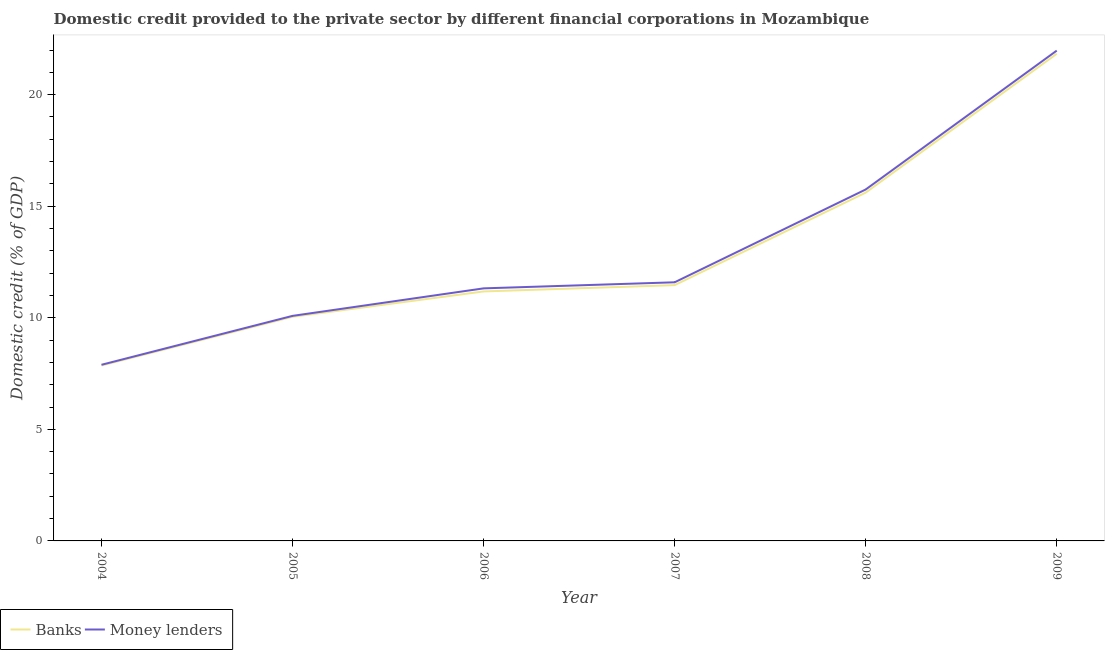How many different coloured lines are there?
Your answer should be very brief. 2. Is the number of lines equal to the number of legend labels?
Your response must be concise. Yes. What is the domestic credit provided by banks in 2007?
Ensure brevity in your answer.  11.46. Across all years, what is the maximum domestic credit provided by money lenders?
Ensure brevity in your answer.  21.97. Across all years, what is the minimum domestic credit provided by banks?
Provide a short and direct response. 7.86. In which year was the domestic credit provided by money lenders minimum?
Make the answer very short. 2004. What is the total domestic credit provided by banks in the graph?
Give a very brief answer. 77.99. What is the difference between the domestic credit provided by money lenders in 2004 and that in 2008?
Give a very brief answer. -7.86. What is the difference between the domestic credit provided by banks in 2005 and the domestic credit provided by money lenders in 2004?
Your response must be concise. 2.15. What is the average domestic credit provided by banks per year?
Offer a very short reply. 13. In the year 2005, what is the difference between the domestic credit provided by money lenders and domestic credit provided by banks?
Keep it short and to the point. 0.04. What is the ratio of the domestic credit provided by banks in 2006 to that in 2008?
Make the answer very short. 0.72. Is the domestic credit provided by banks in 2007 less than that in 2008?
Offer a very short reply. Yes. Is the difference between the domestic credit provided by banks in 2004 and 2005 greater than the difference between the domestic credit provided by money lenders in 2004 and 2005?
Provide a succinct answer. Yes. What is the difference between the highest and the second highest domestic credit provided by banks?
Give a very brief answer. 6.22. What is the difference between the highest and the lowest domestic credit provided by banks?
Make the answer very short. 13.97. Is the sum of the domestic credit provided by banks in 2004 and 2007 greater than the maximum domestic credit provided by money lenders across all years?
Your response must be concise. No. Does the domestic credit provided by money lenders monotonically increase over the years?
Provide a short and direct response. Yes. Is the domestic credit provided by money lenders strictly less than the domestic credit provided by banks over the years?
Your answer should be very brief. No. What is the difference between two consecutive major ticks on the Y-axis?
Ensure brevity in your answer.  5. Does the graph contain grids?
Keep it short and to the point. No. How are the legend labels stacked?
Your response must be concise. Horizontal. What is the title of the graph?
Offer a terse response. Domestic credit provided to the private sector by different financial corporations in Mozambique. What is the label or title of the Y-axis?
Your answer should be very brief. Domestic credit (% of GDP). What is the Domestic credit (% of GDP) of Banks in 2004?
Offer a very short reply. 7.86. What is the Domestic credit (% of GDP) of Money lenders in 2004?
Give a very brief answer. 7.89. What is the Domestic credit (% of GDP) of Banks in 2005?
Ensure brevity in your answer.  10.04. What is the Domestic credit (% of GDP) in Money lenders in 2005?
Your answer should be compact. 10.09. What is the Domestic credit (% of GDP) of Banks in 2006?
Make the answer very short. 11.18. What is the Domestic credit (% of GDP) of Money lenders in 2006?
Provide a short and direct response. 11.32. What is the Domestic credit (% of GDP) in Banks in 2007?
Offer a terse response. 11.46. What is the Domestic credit (% of GDP) of Money lenders in 2007?
Provide a short and direct response. 11.59. What is the Domestic credit (% of GDP) in Banks in 2008?
Offer a very short reply. 15.61. What is the Domestic credit (% of GDP) of Money lenders in 2008?
Your answer should be very brief. 15.75. What is the Domestic credit (% of GDP) in Banks in 2009?
Offer a very short reply. 21.83. What is the Domestic credit (% of GDP) of Money lenders in 2009?
Offer a very short reply. 21.97. Across all years, what is the maximum Domestic credit (% of GDP) in Banks?
Offer a terse response. 21.83. Across all years, what is the maximum Domestic credit (% of GDP) in Money lenders?
Provide a short and direct response. 21.97. Across all years, what is the minimum Domestic credit (% of GDP) of Banks?
Offer a very short reply. 7.86. Across all years, what is the minimum Domestic credit (% of GDP) of Money lenders?
Provide a succinct answer. 7.89. What is the total Domestic credit (% of GDP) of Banks in the graph?
Offer a very short reply. 77.99. What is the total Domestic credit (% of GDP) in Money lenders in the graph?
Ensure brevity in your answer.  78.61. What is the difference between the Domestic credit (% of GDP) of Banks in 2004 and that in 2005?
Your answer should be very brief. -2.18. What is the difference between the Domestic credit (% of GDP) in Money lenders in 2004 and that in 2005?
Offer a very short reply. -2.19. What is the difference between the Domestic credit (% of GDP) of Banks in 2004 and that in 2006?
Give a very brief answer. -3.32. What is the difference between the Domestic credit (% of GDP) of Money lenders in 2004 and that in 2006?
Provide a succinct answer. -3.42. What is the difference between the Domestic credit (% of GDP) of Banks in 2004 and that in 2007?
Your answer should be compact. -3.6. What is the difference between the Domestic credit (% of GDP) in Money lenders in 2004 and that in 2007?
Provide a short and direct response. -3.7. What is the difference between the Domestic credit (% of GDP) in Banks in 2004 and that in 2008?
Provide a succinct answer. -7.75. What is the difference between the Domestic credit (% of GDP) in Money lenders in 2004 and that in 2008?
Your answer should be very brief. -7.86. What is the difference between the Domestic credit (% of GDP) of Banks in 2004 and that in 2009?
Give a very brief answer. -13.97. What is the difference between the Domestic credit (% of GDP) of Money lenders in 2004 and that in 2009?
Offer a terse response. -14.08. What is the difference between the Domestic credit (% of GDP) of Banks in 2005 and that in 2006?
Keep it short and to the point. -1.14. What is the difference between the Domestic credit (% of GDP) of Money lenders in 2005 and that in 2006?
Your response must be concise. -1.23. What is the difference between the Domestic credit (% of GDP) in Banks in 2005 and that in 2007?
Give a very brief answer. -1.42. What is the difference between the Domestic credit (% of GDP) in Money lenders in 2005 and that in 2007?
Offer a terse response. -1.51. What is the difference between the Domestic credit (% of GDP) in Banks in 2005 and that in 2008?
Provide a succinct answer. -5.57. What is the difference between the Domestic credit (% of GDP) in Money lenders in 2005 and that in 2008?
Your answer should be very brief. -5.66. What is the difference between the Domestic credit (% of GDP) in Banks in 2005 and that in 2009?
Offer a terse response. -11.79. What is the difference between the Domestic credit (% of GDP) in Money lenders in 2005 and that in 2009?
Provide a succinct answer. -11.89. What is the difference between the Domestic credit (% of GDP) of Banks in 2006 and that in 2007?
Offer a terse response. -0.28. What is the difference between the Domestic credit (% of GDP) of Money lenders in 2006 and that in 2007?
Your answer should be compact. -0.27. What is the difference between the Domestic credit (% of GDP) of Banks in 2006 and that in 2008?
Ensure brevity in your answer.  -4.43. What is the difference between the Domestic credit (% of GDP) in Money lenders in 2006 and that in 2008?
Your answer should be compact. -4.43. What is the difference between the Domestic credit (% of GDP) of Banks in 2006 and that in 2009?
Offer a terse response. -10.65. What is the difference between the Domestic credit (% of GDP) in Money lenders in 2006 and that in 2009?
Make the answer very short. -10.66. What is the difference between the Domestic credit (% of GDP) in Banks in 2007 and that in 2008?
Ensure brevity in your answer.  -4.15. What is the difference between the Domestic credit (% of GDP) of Money lenders in 2007 and that in 2008?
Your answer should be very brief. -4.16. What is the difference between the Domestic credit (% of GDP) in Banks in 2007 and that in 2009?
Your response must be concise. -10.37. What is the difference between the Domestic credit (% of GDP) of Money lenders in 2007 and that in 2009?
Your response must be concise. -10.38. What is the difference between the Domestic credit (% of GDP) in Banks in 2008 and that in 2009?
Your response must be concise. -6.22. What is the difference between the Domestic credit (% of GDP) of Money lenders in 2008 and that in 2009?
Provide a succinct answer. -6.22. What is the difference between the Domestic credit (% of GDP) of Banks in 2004 and the Domestic credit (% of GDP) of Money lenders in 2005?
Provide a succinct answer. -2.22. What is the difference between the Domestic credit (% of GDP) of Banks in 2004 and the Domestic credit (% of GDP) of Money lenders in 2006?
Your answer should be very brief. -3.46. What is the difference between the Domestic credit (% of GDP) in Banks in 2004 and the Domestic credit (% of GDP) in Money lenders in 2007?
Make the answer very short. -3.73. What is the difference between the Domestic credit (% of GDP) of Banks in 2004 and the Domestic credit (% of GDP) of Money lenders in 2008?
Make the answer very short. -7.89. What is the difference between the Domestic credit (% of GDP) of Banks in 2004 and the Domestic credit (% of GDP) of Money lenders in 2009?
Provide a succinct answer. -14.11. What is the difference between the Domestic credit (% of GDP) in Banks in 2005 and the Domestic credit (% of GDP) in Money lenders in 2006?
Make the answer very short. -1.27. What is the difference between the Domestic credit (% of GDP) of Banks in 2005 and the Domestic credit (% of GDP) of Money lenders in 2007?
Provide a succinct answer. -1.55. What is the difference between the Domestic credit (% of GDP) in Banks in 2005 and the Domestic credit (% of GDP) in Money lenders in 2008?
Offer a very short reply. -5.71. What is the difference between the Domestic credit (% of GDP) of Banks in 2005 and the Domestic credit (% of GDP) of Money lenders in 2009?
Your answer should be very brief. -11.93. What is the difference between the Domestic credit (% of GDP) of Banks in 2006 and the Domestic credit (% of GDP) of Money lenders in 2007?
Your response must be concise. -0.41. What is the difference between the Domestic credit (% of GDP) of Banks in 2006 and the Domestic credit (% of GDP) of Money lenders in 2008?
Keep it short and to the point. -4.57. What is the difference between the Domestic credit (% of GDP) of Banks in 2006 and the Domestic credit (% of GDP) of Money lenders in 2009?
Give a very brief answer. -10.79. What is the difference between the Domestic credit (% of GDP) in Banks in 2007 and the Domestic credit (% of GDP) in Money lenders in 2008?
Keep it short and to the point. -4.29. What is the difference between the Domestic credit (% of GDP) of Banks in 2007 and the Domestic credit (% of GDP) of Money lenders in 2009?
Keep it short and to the point. -10.51. What is the difference between the Domestic credit (% of GDP) of Banks in 2008 and the Domestic credit (% of GDP) of Money lenders in 2009?
Your response must be concise. -6.36. What is the average Domestic credit (% of GDP) in Banks per year?
Keep it short and to the point. 13. What is the average Domestic credit (% of GDP) of Money lenders per year?
Make the answer very short. 13.1. In the year 2004, what is the difference between the Domestic credit (% of GDP) of Banks and Domestic credit (% of GDP) of Money lenders?
Provide a short and direct response. -0.03. In the year 2005, what is the difference between the Domestic credit (% of GDP) in Banks and Domestic credit (% of GDP) in Money lenders?
Your answer should be compact. -0.04. In the year 2006, what is the difference between the Domestic credit (% of GDP) of Banks and Domestic credit (% of GDP) of Money lenders?
Ensure brevity in your answer.  -0.14. In the year 2007, what is the difference between the Domestic credit (% of GDP) in Banks and Domestic credit (% of GDP) in Money lenders?
Ensure brevity in your answer.  -0.13. In the year 2008, what is the difference between the Domestic credit (% of GDP) in Banks and Domestic credit (% of GDP) in Money lenders?
Offer a very short reply. -0.14. In the year 2009, what is the difference between the Domestic credit (% of GDP) of Banks and Domestic credit (% of GDP) of Money lenders?
Your answer should be compact. -0.14. What is the ratio of the Domestic credit (% of GDP) of Banks in 2004 to that in 2005?
Give a very brief answer. 0.78. What is the ratio of the Domestic credit (% of GDP) of Money lenders in 2004 to that in 2005?
Your answer should be very brief. 0.78. What is the ratio of the Domestic credit (% of GDP) in Banks in 2004 to that in 2006?
Make the answer very short. 0.7. What is the ratio of the Domestic credit (% of GDP) in Money lenders in 2004 to that in 2006?
Offer a very short reply. 0.7. What is the ratio of the Domestic credit (% of GDP) of Banks in 2004 to that in 2007?
Your response must be concise. 0.69. What is the ratio of the Domestic credit (% of GDP) in Money lenders in 2004 to that in 2007?
Your response must be concise. 0.68. What is the ratio of the Domestic credit (% of GDP) in Banks in 2004 to that in 2008?
Give a very brief answer. 0.5. What is the ratio of the Domestic credit (% of GDP) in Money lenders in 2004 to that in 2008?
Offer a very short reply. 0.5. What is the ratio of the Domestic credit (% of GDP) in Banks in 2004 to that in 2009?
Your answer should be compact. 0.36. What is the ratio of the Domestic credit (% of GDP) of Money lenders in 2004 to that in 2009?
Give a very brief answer. 0.36. What is the ratio of the Domestic credit (% of GDP) in Banks in 2005 to that in 2006?
Offer a very short reply. 0.9. What is the ratio of the Domestic credit (% of GDP) in Money lenders in 2005 to that in 2006?
Keep it short and to the point. 0.89. What is the ratio of the Domestic credit (% of GDP) in Banks in 2005 to that in 2007?
Provide a short and direct response. 0.88. What is the ratio of the Domestic credit (% of GDP) of Money lenders in 2005 to that in 2007?
Give a very brief answer. 0.87. What is the ratio of the Domestic credit (% of GDP) in Banks in 2005 to that in 2008?
Offer a terse response. 0.64. What is the ratio of the Domestic credit (% of GDP) of Money lenders in 2005 to that in 2008?
Offer a terse response. 0.64. What is the ratio of the Domestic credit (% of GDP) in Banks in 2005 to that in 2009?
Your response must be concise. 0.46. What is the ratio of the Domestic credit (% of GDP) of Money lenders in 2005 to that in 2009?
Ensure brevity in your answer.  0.46. What is the ratio of the Domestic credit (% of GDP) in Banks in 2006 to that in 2007?
Offer a terse response. 0.98. What is the ratio of the Domestic credit (% of GDP) in Money lenders in 2006 to that in 2007?
Keep it short and to the point. 0.98. What is the ratio of the Domestic credit (% of GDP) in Banks in 2006 to that in 2008?
Give a very brief answer. 0.72. What is the ratio of the Domestic credit (% of GDP) in Money lenders in 2006 to that in 2008?
Make the answer very short. 0.72. What is the ratio of the Domestic credit (% of GDP) of Banks in 2006 to that in 2009?
Offer a terse response. 0.51. What is the ratio of the Domestic credit (% of GDP) in Money lenders in 2006 to that in 2009?
Your answer should be very brief. 0.52. What is the ratio of the Domestic credit (% of GDP) of Banks in 2007 to that in 2008?
Provide a short and direct response. 0.73. What is the ratio of the Domestic credit (% of GDP) in Money lenders in 2007 to that in 2008?
Provide a succinct answer. 0.74. What is the ratio of the Domestic credit (% of GDP) of Banks in 2007 to that in 2009?
Provide a succinct answer. 0.53. What is the ratio of the Domestic credit (% of GDP) in Money lenders in 2007 to that in 2009?
Your response must be concise. 0.53. What is the ratio of the Domestic credit (% of GDP) in Banks in 2008 to that in 2009?
Ensure brevity in your answer.  0.71. What is the ratio of the Domestic credit (% of GDP) of Money lenders in 2008 to that in 2009?
Your answer should be compact. 0.72. What is the difference between the highest and the second highest Domestic credit (% of GDP) of Banks?
Your answer should be compact. 6.22. What is the difference between the highest and the second highest Domestic credit (% of GDP) in Money lenders?
Keep it short and to the point. 6.22. What is the difference between the highest and the lowest Domestic credit (% of GDP) of Banks?
Make the answer very short. 13.97. What is the difference between the highest and the lowest Domestic credit (% of GDP) of Money lenders?
Ensure brevity in your answer.  14.08. 